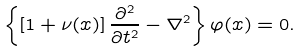<formula> <loc_0><loc_0><loc_500><loc_500>\left \{ \left [ 1 + \nu ( x ) \right ] \frac { \partial ^ { 2 } } { \partial t ^ { 2 } } - \nabla ^ { 2 } \right \} \varphi ( x ) = 0 .</formula> 